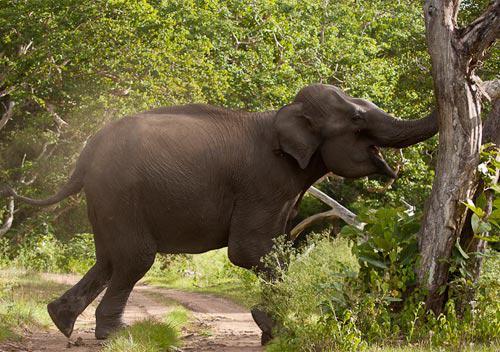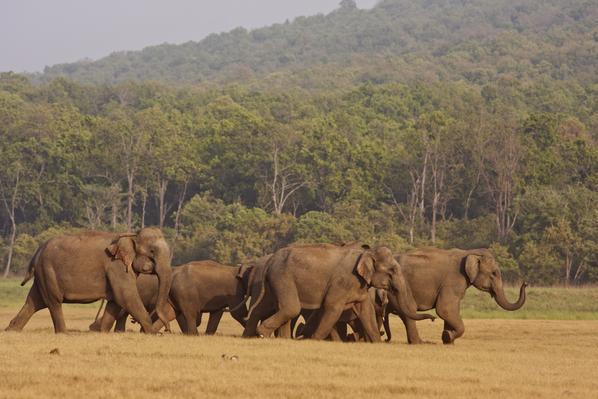The first image is the image on the left, the second image is the image on the right. Assess this claim about the two images: "There are less than three elephants in at least one of the images.". Correct or not? Answer yes or no. Yes. The first image is the image on the left, the second image is the image on the right. Analyze the images presented: Is the assertion "An image shows multiple people in a scene containing several elephants." valid? Answer yes or no. No. 